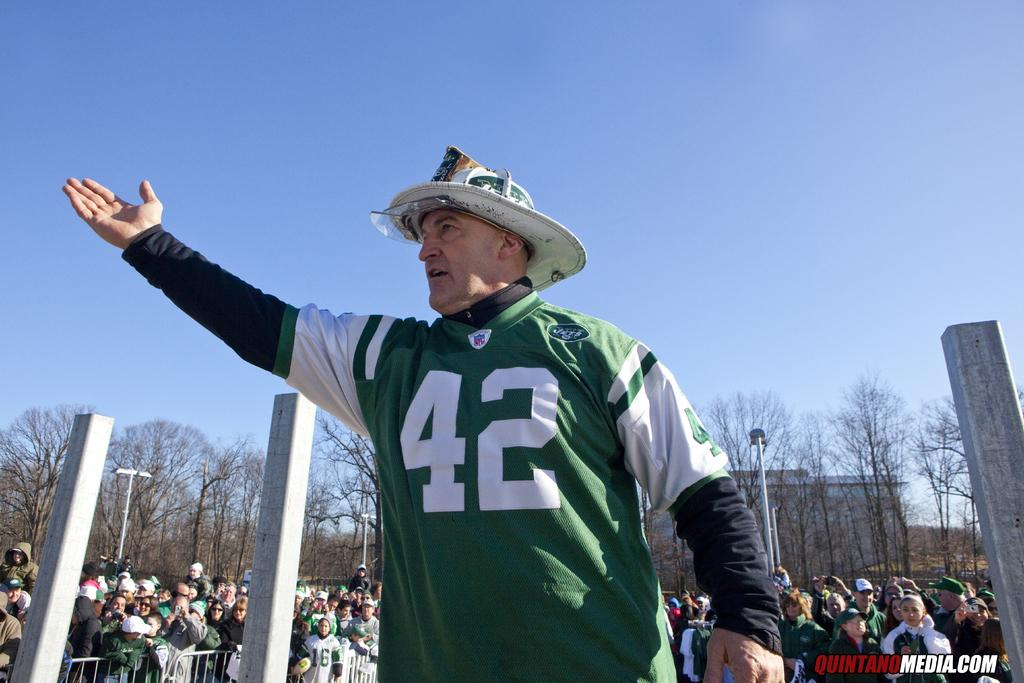<image>
Render a clear and concise summary of the photo. A man wearing a green and white jersey with a 42 on it extends his arm. 